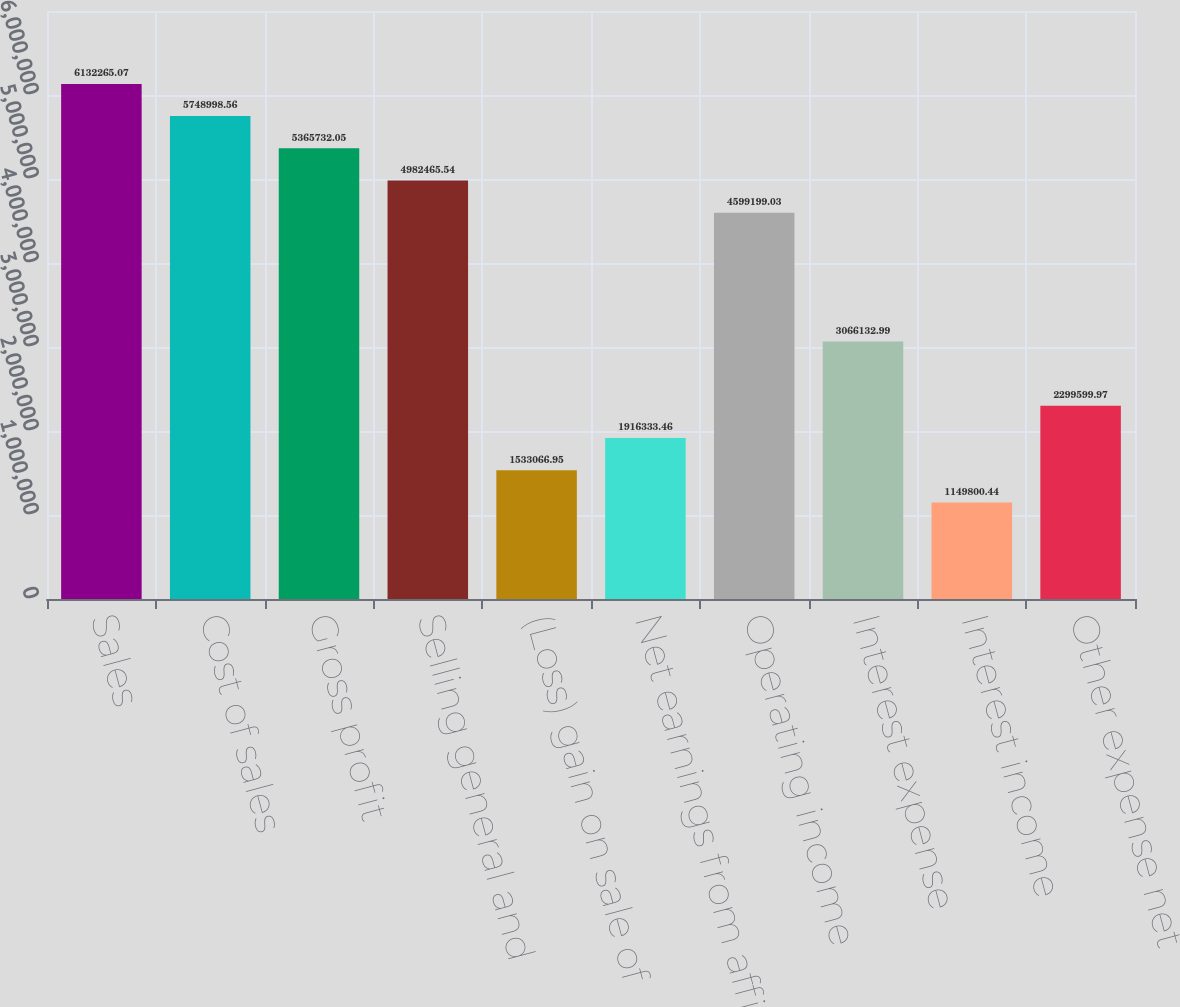Convert chart to OTSL. <chart><loc_0><loc_0><loc_500><loc_500><bar_chart><fcel>Sales<fcel>Cost of sales<fcel>Gross profit<fcel>Selling general and<fcel>(Loss) gain on sale of<fcel>Net earnings from affiliates<fcel>Operating income<fcel>Interest expense<fcel>Interest income<fcel>Other expense net<nl><fcel>6.13227e+06<fcel>5.749e+06<fcel>5.36573e+06<fcel>4.98247e+06<fcel>1.53307e+06<fcel>1.91633e+06<fcel>4.5992e+06<fcel>3.06613e+06<fcel>1.1498e+06<fcel>2.2996e+06<nl></chart> 